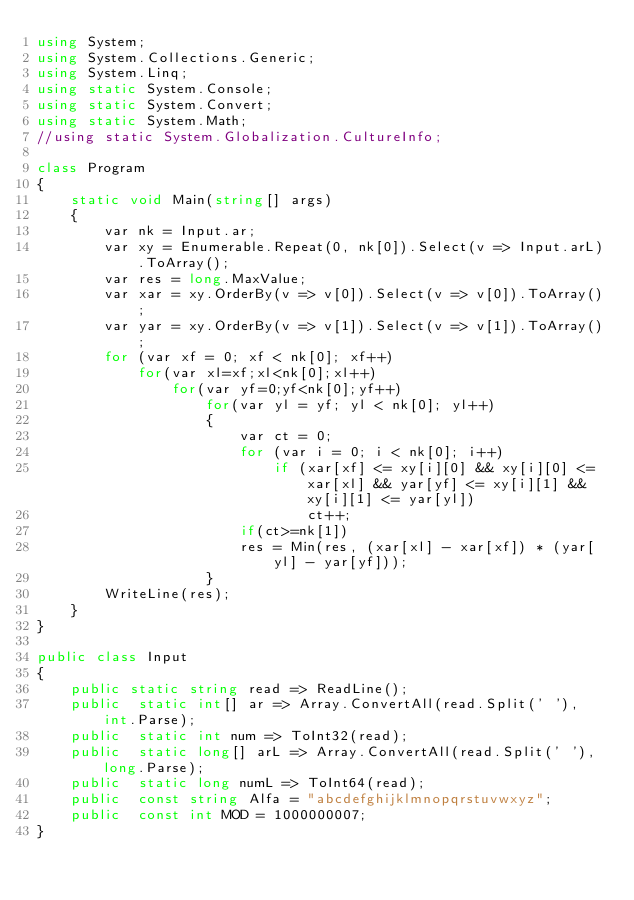Convert code to text. <code><loc_0><loc_0><loc_500><loc_500><_C#_>using System;
using System.Collections.Generic;
using System.Linq;
using static System.Console;
using static System.Convert;
using static System.Math;
//using static System.Globalization.CultureInfo;

class Program
{
    static void Main(string[] args)
    {
        var nk = Input.ar;
        var xy = Enumerable.Repeat(0, nk[0]).Select(v => Input.arL).ToArray();
        var res = long.MaxValue;
        var xar = xy.OrderBy(v => v[0]).Select(v => v[0]).ToArray();
        var yar = xy.OrderBy(v => v[1]).Select(v => v[1]).ToArray();
        for (var xf = 0; xf < nk[0]; xf++)
            for(var xl=xf;xl<nk[0];xl++)
                for(var yf=0;yf<nk[0];yf++)
                    for(var yl = yf; yl < nk[0]; yl++)
                    {
                        var ct = 0;
                        for (var i = 0; i < nk[0]; i++)
                            if (xar[xf] <= xy[i][0] && xy[i][0] <= xar[xl] && yar[yf] <= xy[i][1] && xy[i][1] <= yar[yl])
                                ct++;
                        if(ct>=nk[1])
                        res = Min(res, (xar[xl] - xar[xf]) * (yar[yl] - yar[yf]));
                    }
        WriteLine(res);
    }
}

public class Input
{
    public static string read => ReadLine();
    public  static int[] ar => Array.ConvertAll(read.Split(' '), int.Parse);
    public  static int num => ToInt32(read);
    public  static long[] arL => Array.ConvertAll(read.Split(' '), long.Parse);
    public  static long numL => ToInt64(read);
    public  const string Alfa = "abcdefghijklmnopqrstuvwxyz";
    public  const int MOD = 1000000007;
}
</code> 